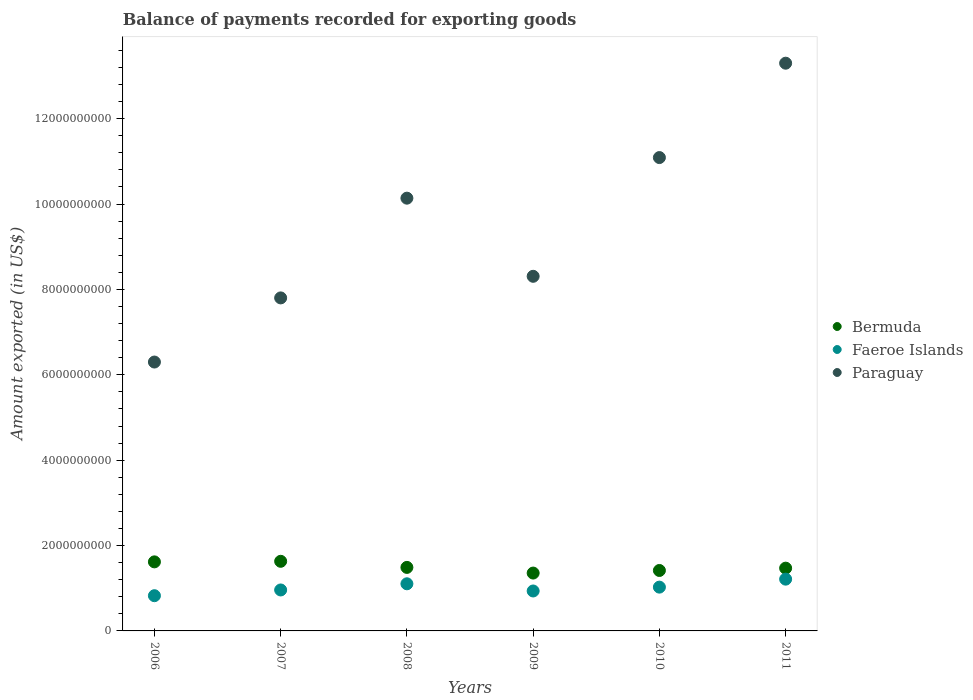What is the amount exported in Faeroe Islands in 2008?
Your answer should be very brief. 1.10e+09. Across all years, what is the maximum amount exported in Bermuda?
Your answer should be very brief. 1.63e+09. Across all years, what is the minimum amount exported in Paraguay?
Keep it short and to the point. 6.30e+09. What is the total amount exported in Paraguay in the graph?
Offer a very short reply. 5.69e+1. What is the difference between the amount exported in Paraguay in 2009 and that in 2010?
Offer a terse response. -2.78e+09. What is the difference between the amount exported in Bermuda in 2009 and the amount exported in Paraguay in 2010?
Provide a succinct answer. -9.73e+09. What is the average amount exported in Bermuda per year?
Ensure brevity in your answer.  1.50e+09. In the year 2011, what is the difference between the amount exported in Paraguay and amount exported in Faeroe Islands?
Provide a succinct answer. 1.21e+1. In how many years, is the amount exported in Bermuda greater than 7200000000 US$?
Your response must be concise. 0. What is the ratio of the amount exported in Faeroe Islands in 2007 to that in 2011?
Make the answer very short. 0.79. Is the amount exported in Bermuda in 2006 less than that in 2009?
Provide a short and direct response. No. What is the difference between the highest and the second highest amount exported in Bermuda?
Your answer should be compact. 1.32e+07. What is the difference between the highest and the lowest amount exported in Paraguay?
Your answer should be very brief. 7.00e+09. Is it the case that in every year, the sum of the amount exported in Faeroe Islands and amount exported in Bermuda  is greater than the amount exported in Paraguay?
Your response must be concise. No. Is the amount exported in Paraguay strictly greater than the amount exported in Faeroe Islands over the years?
Your answer should be compact. Yes. What is the title of the graph?
Ensure brevity in your answer.  Balance of payments recorded for exporting goods. Does "Channel Islands" appear as one of the legend labels in the graph?
Provide a short and direct response. No. What is the label or title of the X-axis?
Your answer should be compact. Years. What is the label or title of the Y-axis?
Your answer should be very brief. Amount exported (in US$). What is the Amount exported (in US$) of Bermuda in 2006?
Offer a terse response. 1.62e+09. What is the Amount exported (in US$) of Faeroe Islands in 2006?
Offer a terse response. 8.25e+08. What is the Amount exported (in US$) of Paraguay in 2006?
Ensure brevity in your answer.  6.30e+09. What is the Amount exported (in US$) of Bermuda in 2007?
Make the answer very short. 1.63e+09. What is the Amount exported (in US$) in Faeroe Islands in 2007?
Your answer should be very brief. 9.60e+08. What is the Amount exported (in US$) of Paraguay in 2007?
Keep it short and to the point. 7.80e+09. What is the Amount exported (in US$) of Bermuda in 2008?
Offer a very short reply. 1.49e+09. What is the Amount exported (in US$) in Faeroe Islands in 2008?
Your answer should be compact. 1.10e+09. What is the Amount exported (in US$) in Paraguay in 2008?
Your answer should be compact. 1.01e+1. What is the Amount exported (in US$) of Bermuda in 2009?
Make the answer very short. 1.36e+09. What is the Amount exported (in US$) in Faeroe Islands in 2009?
Offer a very short reply. 9.36e+08. What is the Amount exported (in US$) of Paraguay in 2009?
Ensure brevity in your answer.  8.31e+09. What is the Amount exported (in US$) of Bermuda in 2010?
Ensure brevity in your answer.  1.42e+09. What is the Amount exported (in US$) of Faeroe Islands in 2010?
Provide a succinct answer. 1.03e+09. What is the Amount exported (in US$) in Paraguay in 2010?
Your response must be concise. 1.11e+1. What is the Amount exported (in US$) in Bermuda in 2011?
Give a very brief answer. 1.47e+09. What is the Amount exported (in US$) of Faeroe Islands in 2011?
Your answer should be very brief. 1.21e+09. What is the Amount exported (in US$) of Paraguay in 2011?
Make the answer very short. 1.33e+1. Across all years, what is the maximum Amount exported (in US$) in Bermuda?
Offer a very short reply. 1.63e+09. Across all years, what is the maximum Amount exported (in US$) of Faeroe Islands?
Keep it short and to the point. 1.21e+09. Across all years, what is the maximum Amount exported (in US$) of Paraguay?
Make the answer very short. 1.33e+1. Across all years, what is the minimum Amount exported (in US$) of Bermuda?
Your response must be concise. 1.36e+09. Across all years, what is the minimum Amount exported (in US$) in Faeroe Islands?
Provide a succinct answer. 8.25e+08. Across all years, what is the minimum Amount exported (in US$) of Paraguay?
Offer a very short reply. 6.30e+09. What is the total Amount exported (in US$) in Bermuda in the graph?
Provide a succinct answer. 8.98e+09. What is the total Amount exported (in US$) in Faeroe Islands in the graph?
Provide a short and direct response. 6.06e+09. What is the total Amount exported (in US$) in Paraguay in the graph?
Provide a succinct answer. 5.69e+1. What is the difference between the Amount exported (in US$) in Bermuda in 2006 and that in 2007?
Ensure brevity in your answer.  -1.32e+07. What is the difference between the Amount exported (in US$) in Faeroe Islands in 2006 and that in 2007?
Your answer should be very brief. -1.35e+08. What is the difference between the Amount exported (in US$) of Paraguay in 2006 and that in 2007?
Ensure brevity in your answer.  -1.50e+09. What is the difference between the Amount exported (in US$) of Bermuda in 2006 and that in 2008?
Give a very brief answer. 1.30e+08. What is the difference between the Amount exported (in US$) of Faeroe Islands in 2006 and that in 2008?
Make the answer very short. -2.79e+08. What is the difference between the Amount exported (in US$) in Paraguay in 2006 and that in 2008?
Provide a short and direct response. -3.84e+09. What is the difference between the Amount exported (in US$) in Bermuda in 2006 and that in 2009?
Keep it short and to the point. 2.62e+08. What is the difference between the Amount exported (in US$) in Faeroe Islands in 2006 and that in 2009?
Ensure brevity in your answer.  -1.11e+08. What is the difference between the Amount exported (in US$) in Paraguay in 2006 and that in 2009?
Give a very brief answer. -2.01e+09. What is the difference between the Amount exported (in US$) in Bermuda in 2006 and that in 2010?
Provide a short and direct response. 2.02e+08. What is the difference between the Amount exported (in US$) in Faeroe Islands in 2006 and that in 2010?
Provide a short and direct response. -2.01e+08. What is the difference between the Amount exported (in US$) in Paraguay in 2006 and that in 2010?
Keep it short and to the point. -4.79e+09. What is the difference between the Amount exported (in US$) of Bermuda in 2006 and that in 2011?
Offer a terse response. 1.47e+08. What is the difference between the Amount exported (in US$) in Faeroe Islands in 2006 and that in 2011?
Offer a very short reply. -3.88e+08. What is the difference between the Amount exported (in US$) in Paraguay in 2006 and that in 2011?
Provide a succinct answer. -7.00e+09. What is the difference between the Amount exported (in US$) of Bermuda in 2007 and that in 2008?
Your response must be concise. 1.43e+08. What is the difference between the Amount exported (in US$) in Faeroe Islands in 2007 and that in 2008?
Provide a short and direct response. -1.45e+08. What is the difference between the Amount exported (in US$) of Paraguay in 2007 and that in 2008?
Provide a short and direct response. -2.34e+09. What is the difference between the Amount exported (in US$) of Bermuda in 2007 and that in 2009?
Make the answer very short. 2.76e+08. What is the difference between the Amount exported (in US$) of Faeroe Islands in 2007 and that in 2009?
Make the answer very short. 2.40e+07. What is the difference between the Amount exported (in US$) in Paraguay in 2007 and that in 2009?
Keep it short and to the point. -5.06e+08. What is the difference between the Amount exported (in US$) in Bermuda in 2007 and that in 2010?
Make the answer very short. 2.15e+08. What is the difference between the Amount exported (in US$) of Faeroe Islands in 2007 and that in 2010?
Offer a very short reply. -6.62e+07. What is the difference between the Amount exported (in US$) in Paraguay in 2007 and that in 2010?
Provide a succinct answer. -3.29e+09. What is the difference between the Amount exported (in US$) in Bermuda in 2007 and that in 2011?
Keep it short and to the point. 1.60e+08. What is the difference between the Amount exported (in US$) in Faeroe Islands in 2007 and that in 2011?
Your response must be concise. -2.53e+08. What is the difference between the Amount exported (in US$) of Paraguay in 2007 and that in 2011?
Give a very brief answer. -5.50e+09. What is the difference between the Amount exported (in US$) of Bermuda in 2008 and that in 2009?
Your response must be concise. 1.33e+08. What is the difference between the Amount exported (in US$) in Faeroe Islands in 2008 and that in 2009?
Offer a terse response. 1.69e+08. What is the difference between the Amount exported (in US$) in Paraguay in 2008 and that in 2009?
Make the answer very short. 1.83e+09. What is the difference between the Amount exported (in US$) of Bermuda in 2008 and that in 2010?
Ensure brevity in your answer.  7.21e+07. What is the difference between the Amount exported (in US$) of Faeroe Islands in 2008 and that in 2010?
Keep it short and to the point. 7.85e+07. What is the difference between the Amount exported (in US$) in Paraguay in 2008 and that in 2010?
Keep it short and to the point. -9.51e+08. What is the difference between the Amount exported (in US$) of Bermuda in 2008 and that in 2011?
Your response must be concise. 1.78e+07. What is the difference between the Amount exported (in US$) in Faeroe Islands in 2008 and that in 2011?
Provide a succinct answer. -1.09e+08. What is the difference between the Amount exported (in US$) in Paraguay in 2008 and that in 2011?
Offer a terse response. -3.16e+09. What is the difference between the Amount exported (in US$) of Bermuda in 2009 and that in 2010?
Provide a short and direct response. -6.07e+07. What is the difference between the Amount exported (in US$) of Faeroe Islands in 2009 and that in 2010?
Make the answer very short. -9.01e+07. What is the difference between the Amount exported (in US$) in Paraguay in 2009 and that in 2010?
Your answer should be very brief. -2.78e+09. What is the difference between the Amount exported (in US$) of Bermuda in 2009 and that in 2011?
Your answer should be very brief. -1.15e+08. What is the difference between the Amount exported (in US$) of Faeroe Islands in 2009 and that in 2011?
Offer a terse response. -2.77e+08. What is the difference between the Amount exported (in US$) of Paraguay in 2009 and that in 2011?
Your response must be concise. -4.99e+09. What is the difference between the Amount exported (in US$) of Bermuda in 2010 and that in 2011?
Provide a short and direct response. -5.44e+07. What is the difference between the Amount exported (in US$) in Faeroe Islands in 2010 and that in 2011?
Make the answer very short. -1.87e+08. What is the difference between the Amount exported (in US$) of Paraguay in 2010 and that in 2011?
Provide a succinct answer. -2.21e+09. What is the difference between the Amount exported (in US$) in Bermuda in 2006 and the Amount exported (in US$) in Faeroe Islands in 2007?
Make the answer very short. 6.58e+08. What is the difference between the Amount exported (in US$) in Bermuda in 2006 and the Amount exported (in US$) in Paraguay in 2007?
Your answer should be very brief. -6.18e+09. What is the difference between the Amount exported (in US$) in Faeroe Islands in 2006 and the Amount exported (in US$) in Paraguay in 2007?
Your answer should be compact. -6.98e+09. What is the difference between the Amount exported (in US$) of Bermuda in 2006 and the Amount exported (in US$) of Faeroe Islands in 2008?
Give a very brief answer. 5.13e+08. What is the difference between the Amount exported (in US$) in Bermuda in 2006 and the Amount exported (in US$) in Paraguay in 2008?
Ensure brevity in your answer.  -8.52e+09. What is the difference between the Amount exported (in US$) of Faeroe Islands in 2006 and the Amount exported (in US$) of Paraguay in 2008?
Offer a very short reply. -9.31e+09. What is the difference between the Amount exported (in US$) of Bermuda in 2006 and the Amount exported (in US$) of Faeroe Islands in 2009?
Make the answer very short. 6.82e+08. What is the difference between the Amount exported (in US$) of Bermuda in 2006 and the Amount exported (in US$) of Paraguay in 2009?
Provide a succinct answer. -6.69e+09. What is the difference between the Amount exported (in US$) of Faeroe Islands in 2006 and the Amount exported (in US$) of Paraguay in 2009?
Provide a short and direct response. -7.48e+09. What is the difference between the Amount exported (in US$) of Bermuda in 2006 and the Amount exported (in US$) of Faeroe Islands in 2010?
Make the answer very short. 5.92e+08. What is the difference between the Amount exported (in US$) of Bermuda in 2006 and the Amount exported (in US$) of Paraguay in 2010?
Your answer should be compact. -9.47e+09. What is the difference between the Amount exported (in US$) of Faeroe Islands in 2006 and the Amount exported (in US$) of Paraguay in 2010?
Offer a terse response. -1.03e+1. What is the difference between the Amount exported (in US$) in Bermuda in 2006 and the Amount exported (in US$) in Faeroe Islands in 2011?
Your answer should be compact. 4.05e+08. What is the difference between the Amount exported (in US$) of Bermuda in 2006 and the Amount exported (in US$) of Paraguay in 2011?
Offer a very short reply. -1.17e+1. What is the difference between the Amount exported (in US$) of Faeroe Islands in 2006 and the Amount exported (in US$) of Paraguay in 2011?
Ensure brevity in your answer.  -1.25e+1. What is the difference between the Amount exported (in US$) of Bermuda in 2007 and the Amount exported (in US$) of Faeroe Islands in 2008?
Provide a short and direct response. 5.27e+08. What is the difference between the Amount exported (in US$) of Bermuda in 2007 and the Amount exported (in US$) of Paraguay in 2008?
Ensure brevity in your answer.  -8.51e+09. What is the difference between the Amount exported (in US$) of Faeroe Islands in 2007 and the Amount exported (in US$) of Paraguay in 2008?
Your answer should be compact. -9.18e+09. What is the difference between the Amount exported (in US$) in Bermuda in 2007 and the Amount exported (in US$) in Faeroe Islands in 2009?
Give a very brief answer. 6.95e+08. What is the difference between the Amount exported (in US$) in Bermuda in 2007 and the Amount exported (in US$) in Paraguay in 2009?
Your answer should be compact. -6.68e+09. What is the difference between the Amount exported (in US$) of Faeroe Islands in 2007 and the Amount exported (in US$) of Paraguay in 2009?
Ensure brevity in your answer.  -7.35e+09. What is the difference between the Amount exported (in US$) of Bermuda in 2007 and the Amount exported (in US$) of Faeroe Islands in 2010?
Your answer should be compact. 6.05e+08. What is the difference between the Amount exported (in US$) in Bermuda in 2007 and the Amount exported (in US$) in Paraguay in 2010?
Your response must be concise. -9.46e+09. What is the difference between the Amount exported (in US$) of Faeroe Islands in 2007 and the Amount exported (in US$) of Paraguay in 2010?
Offer a very short reply. -1.01e+1. What is the difference between the Amount exported (in US$) of Bermuda in 2007 and the Amount exported (in US$) of Faeroe Islands in 2011?
Give a very brief answer. 4.18e+08. What is the difference between the Amount exported (in US$) of Bermuda in 2007 and the Amount exported (in US$) of Paraguay in 2011?
Provide a short and direct response. -1.17e+1. What is the difference between the Amount exported (in US$) of Faeroe Islands in 2007 and the Amount exported (in US$) of Paraguay in 2011?
Your response must be concise. -1.23e+1. What is the difference between the Amount exported (in US$) of Bermuda in 2008 and the Amount exported (in US$) of Faeroe Islands in 2009?
Keep it short and to the point. 5.53e+08. What is the difference between the Amount exported (in US$) of Bermuda in 2008 and the Amount exported (in US$) of Paraguay in 2009?
Your response must be concise. -6.82e+09. What is the difference between the Amount exported (in US$) of Faeroe Islands in 2008 and the Amount exported (in US$) of Paraguay in 2009?
Your answer should be compact. -7.20e+09. What is the difference between the Amount exported (in US$) of Bermuda in 2008 and the Amount exported (in US$) of Faeroe Islands in 2010?
Your answer should be very brief. 4.62e+08. What is the difference between the Amount exported (in US$) of Bermuda in 2008 and the Amount exported (in US$) of Paraguay in 2010?
Keep it short and to the point. -9.60e+09. What is the difference between the Amount exported (in US$) of Faeroe Islands in 2008 and the Amount exported (in US$) of Paraguay in 2010?
Ensure brevity in your answer.  -9.99e+09. What is the difference between the Amount exported (in US$) in Bermuda in 2008 and the Amount exported (in US$) in Faeroe Islands in 2011?
Provide a succinct answer. 2.75e+08. What is the difference between the Amount exported (in US$) in Bermuda in 2008 and the Amount exported (in US$) in Paraguay in 2011?
Your response must be concise. -1.18e+1. What is the difference between the Amount exported (in US$) in Faeroe Islands in 2008 and the Amount exported (in US$) in Paraguay in 2011?
Provide a succinct answer. -1.22e+1. What is the difference between the Amount exported (in US$) of Bermuda in 2009 and the Amount exported (in US$) of Faeroe Islands in 2010?
Provide a short and direct response. 3.30e+08. What is the difference between the Amount exported (in US$) in Bermuda in 2009 and the Amount exported (in US$) in Paraguay in 2010?
Provide a succinct answer. -9.73e+09. What is the difference between the Amount exported (in US$) of Faeroe Islands in 2009 and the Amount exported (in US$) of Paraguay in 2010?
Keep it short and to the point. -1.02e+1. What is the difference between the Amount exported (in US$) of Bermuda in 2009 and the Amount exported (in US$) of Faeroe Islands in 2011?
Make the answer very short. 1.43e+08. What is the difference between the Amount exported (in US$) in Bermuda in 2009 and the Amount exported (in US$) in Paraguay in 2011?
Provide a succinct answer. -1.19e+1. What is the difference between the Amount exported (in US$) of Faeroe Islands in 2009 and the Amount exported (in US$) of Paraguay in 2011?
Keep it short and to the point. -1.24e+1. What is the difference between the Amount exported (in US$) of Bermuda in 2010 and the Amount exported (in US$) of Faeroe Islands in 2011?
Give a very brief answer. 2.03e+08. What is the difference between the Amount exported (in US$) of Bermuda in 2010 and the Amount exported (in US$) of Paraguay in 2011?
Your answer should be compact. -1.19e+1. What is the difference between the Amount exported (in US$) of Faeroe Islands in 2010 and the Amount exported (in US$) of Paraguay in 2011?
Your answer should be very brief. -1.23e+1. What is the average Amount exported (in US$) of Bermuda per year?
Provide a succinct answer. 1.50e+09. What is the average Amount exported (in US$) of Faeroe Islands per year?
Your answer should be compact. 1.01e+09. What is the average Amount exported (in US$) in Paraguay per year?
Your answer should be very brief. 9.49e+09. In the year 2006, what is the difference between the Amount exported (in US$) in Bermuda and Amount exported (in US$) in Faeroe Islands?
Offer a very short reply. 7.93e+08. In the year 2006, what is the difference between the Amount exported (in US$) of Bermuda and Amount exported (in US$) of Paraguay?
Provide a short and direct response. -4.68e+09. In the year 2006, what is the difference between the Amount exported (in US$) in Faeroe Islands and Amount exported (in US$) in Paraguay?
Your response must be concise. -5.47e+09. In the year 2007, what is the difference between the Amount exported (in US$) of Bermuda and Amount exported (in US$) of Faeroe Islands?
Provide a succinct answer. 6.71e+08. In the year 2007, what is the difference between the Amount exported (in US$) in Bermuda and Amount exported (in US$) in Paraguay?
Provide a short and direct response. -6.17e+09. In the year 2007, what is the difference between the Amount exported (in US$) in Faeroe Islands and Amount exported (in US$) in Paraguay?
Provide a succinct answer. -6.84e+09. In the year 2008, what is the difference between the Amount exported (in US$) of Bermuda and Amount exported (in US$) of Faeroe Islands?
Your answer should be very brief. 3.84e+08. In the year 2008, what is the difference between the Amount exported (in US$) in Bermuda and Amount exported (in US$) in Paraguay?
Your answer should be compact. -8.65e+09. In the year 2008, what is the difference between the Amount exported (in US$) in Faeroe Islands and Amount exported (in US$) in Paraguay?
Offer a very short reply. -9.03e+09. In the year 2009, what is the difference between the Amount exported (in US$) in Bermuda and Amount exported (in US$) in Faeroe Islands?
Your answer should be compact. 4.20e+08. In the year 2009, what is the difference between the Amount exported (in US$) of Bermuda and Amount exported (in US$) of Paraguay?
Make the answer very short. -6.95e+09. In the year 2009, what is the difference between the Amount exported (in US$) in Faeroe Islands and Amount exported (in US$) in Paraguay?
Give a very brief answer. -7.37e+09. In the year 2010, what is the difference between the Amount exported (in US$) of Bermuda and Amount exported (in US$) of Faeroe Islands?
Ensure brevity in your answer.  3.90e+08. In the year 2010, what is the difference between the Amount exported (in US$) in Bermuda and Amount exported (in US$) in Paraguay?
Your response must be concise. -9.67e+09. In the year 2010, what is the difference between the Amount exported (in US$) in Faeroe Islands and Amount exported (in US$) in Paraguay?
Give a very brief answer. -1.01e+1. In the year 2011, what is the difference between the Amount exported (in US$) of Bermuda and Amount exported (in US$) of Faeroe Islands?
Provide a short and direct response. 2.58e+08. In the year 2011, what is the difference between the Amount exported (in US$) in Bermuda and Amount exported (in US$) in Paraguay?
Keep it short and to the point. -1.18e+1. In the year 2011, what is the difference between the Amount exported (in US$) in Faeroe Islands and Amount exported (in US$) in Paraguay?
Keep it short and to the point. -1.21e+1. What is the ratio of the Amount exported (in US$) of Faeroe Islands in 2006 to that in 2007?
Make the answer very short. 0.86. What is the ratio of the Amount exported (in US$) in Paraguay in 2006 to that in 2007?
Offer a very short reply. 0.81. What is the ratio of the Amount exported (in US$) of Bermuda in 2006 to that in 2008?
Ensure brevity in your answer.  1.09. What is the ratio of the Amount exported (in US$) of Faeroe Islands in 2006 to that in 2008?
Ensure brevity in your answer.  0.75. What is the ratio of the Amount exported (in US$) of Paraguay in 2006 to that in 2008?
Provide a short and direct response. 0.62. What is the ratio of the Amount exported (in US$) in Bermuda in 2006 to that in 2009?
Give a very brief answer. 1.19. What is the ratio of the Amount exported (in US$) of Faeroe Islands in 2006 to that in 2009?
Keep it short and to the point. 0.88. What is the ratio of the Amount exported (in US$) of Paraguay in 2006 to that in 2009?
Your response must be concise. 0.76. What is the ratio of the Amount exported (in US$) of Bermuda in 2006 to that in 2010?
Your response must be concise. 1.14. What is the ratio of the Amount exported (in US$) in Faeroe Islands in 2006 to that in 2010?
Your answer should be compact. 0.8. What is the ratio of the Amount exported (in US$) of Paraguay in 2006 to that in 2010?
Offer a very short reply. 0.57. What is the ratio of the Amount exported (in US$) in Bermuda in 2006 to that in 2011?
Your answer should be very brief. 1.1. What is the ratio of the Amount exported (in US$) of Faeroe Islands in 2006 to that in 2011?
Provide a short and direct response. 0.68. What is the ratio of the Amount exported (in US$) in Paraguay in 2006 to that in 2011?
Offer a terse response. 0.47. What is the ratio of the Amount exported (in US$) in Bermuda in 2007 to that in 2008?
Offer a very short reply. 1.1. What is the ratio of the Amount exported (in US$) of Faeroe Islands in 2007 to that in 2008?
Give a very brief answer. 0.87. What is the ratio of the Amount exported (in US$) in Paraguay in 2007 to that in 2008?
Keep it short and to the point. 0.77. What is the ratio of the Amount exported (in US$) in Bermuda in 2007 to that in 2009?
Your response must be concise. 1.2. What is the ratio of the Amount exported (in US$) of Faeroe Islands in 2007 to that in 2009?
Offer a very short reply. 1.03. What is the ratio of the Amount exported (in US$) in Paraguay in 2007 to that in 2009?
Your response must be concise. 0.94. What is the ratio of the Amount exported (in US$) of Bermuda in 2007 to that in 2010?
Offer a very short reply. 1.15. What is the ratio of the Amount exported (in US$) in Faeroe Islands in 2007 to that in 2010?
Give a very brief answer. 0.94. What is the ratio of the Amount exported (in US$) of Paraguay in 2007 to that in 2010?
Your response must be concise. 0.7. What is the ratio of the Amount exported (in US$) of Bermuda in 2007 to that in 2011?
Make the answer very short. 1.11. What is the ratio of the Amount exported (in US$) of Faeroe Islands in 2007 to that in 2011?
Your answer should be compact. 0.79. What is the ratio of the Amount exported (in US$) in Paraguay in 2007 to that in 2011?
Ensure brevity in your answer.  0.59. What is the ratio of the Amount exported (in US$) in Bermuda in 2008 to that in 2009?
Keep it short and to the point. 1.1. What is the ratio of the Amount exported (in US$) of Faeroe Islands in 2008 to that in 2009?
Offer a terse response. 1.18. What is the ratio of the Amount exported (in US$) of Paraguay in 2008 to that in 2009?
Make the answer very short. 1.22. What is the ratio of the Amount exported (in US$) of Bermuda in 2008 to that in 2010?
Keep it short and to the point. 1.05. What is the ratio of the Amount exported (in US$) in Faeroe Islands in 2008 to that in 2010?
Keep it short and to the point. 1.08. What is the ratio of the Amount exported (in US$) in Paraguay in 2008 to that in 2010?
Provide a short and direct response. 0.91. What is the ratio of the Amount exported (in US$) of Bermuda in 2008 to that in 2011?
Give a very brief answer. 1.01. What is the ratio of the Amount exported (in US$) in Faeroe Islands in 2008 to that in 2011?
Give a very brief answer. 0.91. What is the ratio of the Amount exported (in US$) of Paraguay in 2008 to that in 2011?
Provide a short and direct response. 0.76. What is the ratio of the Amount exported (in US$) in Bermuda in 2009 to that in 2010?
Ensure brevity in your answer.  0.96. What is the ratio of the Amount exported (in US$) in Faeroe Islands in 2009 to that in 2010?
Provide a succinct answer. 0.91. What is the ratio of the Amount exported (in US$) of Paraguay in 2009 to that in 2010?
Ensure brevity in your answer.  0.75. What is the ratio of the Amount exported (in US$) of Bermuda in 2009 to that in 2011?
Offer a very short reply. 0.92. What is the ratio of the Amount exported (in US$) in Faeroe Islands in 2009 to that in 2011?
Offer a very short reply. 0.77. What is the ratio of the Amount exported (in US$) in Paraguay in 2009 to that in 2011?
Your response must be concise. 0.62. What is the ratio of the Amount exported (in US$) of Faeroe Islands in 2010 to that in 2011?
Offer a terse response. 0.85. What is the ratio of the Amount exported (in US$) in Paraguay in 2010 to that in 2011?
Keep it short and to the point. 0.83. What is the difference between the highest and the second highest Amount exported (in US$) of Bermuda?
Your answer should be compact. 1.32e+07. What is the difference between the highest and the second highest Amount exported (in US$) in Faeroe Islands?
Provide a short and direct response. 1.09e+08. What is the difference between the highest and the second highest Amount exported (in US$) in Paraguay?
Offer a very short reply. 2.21e+09. What is the difference between the highest and the lowest Amount exported (in US$) in Bermuda?
Ensure brevity in your answer.  2.76e+08. What is the difference between the highest and the lowest Amount exported (in US$) of Faeroe Islands?
Provide a succinct answer. 3.88e+08. What is the difference between the highest and the lowest Amount exported (in US$) of Paraguay?
Your response must be concise. 7.00e+09. 